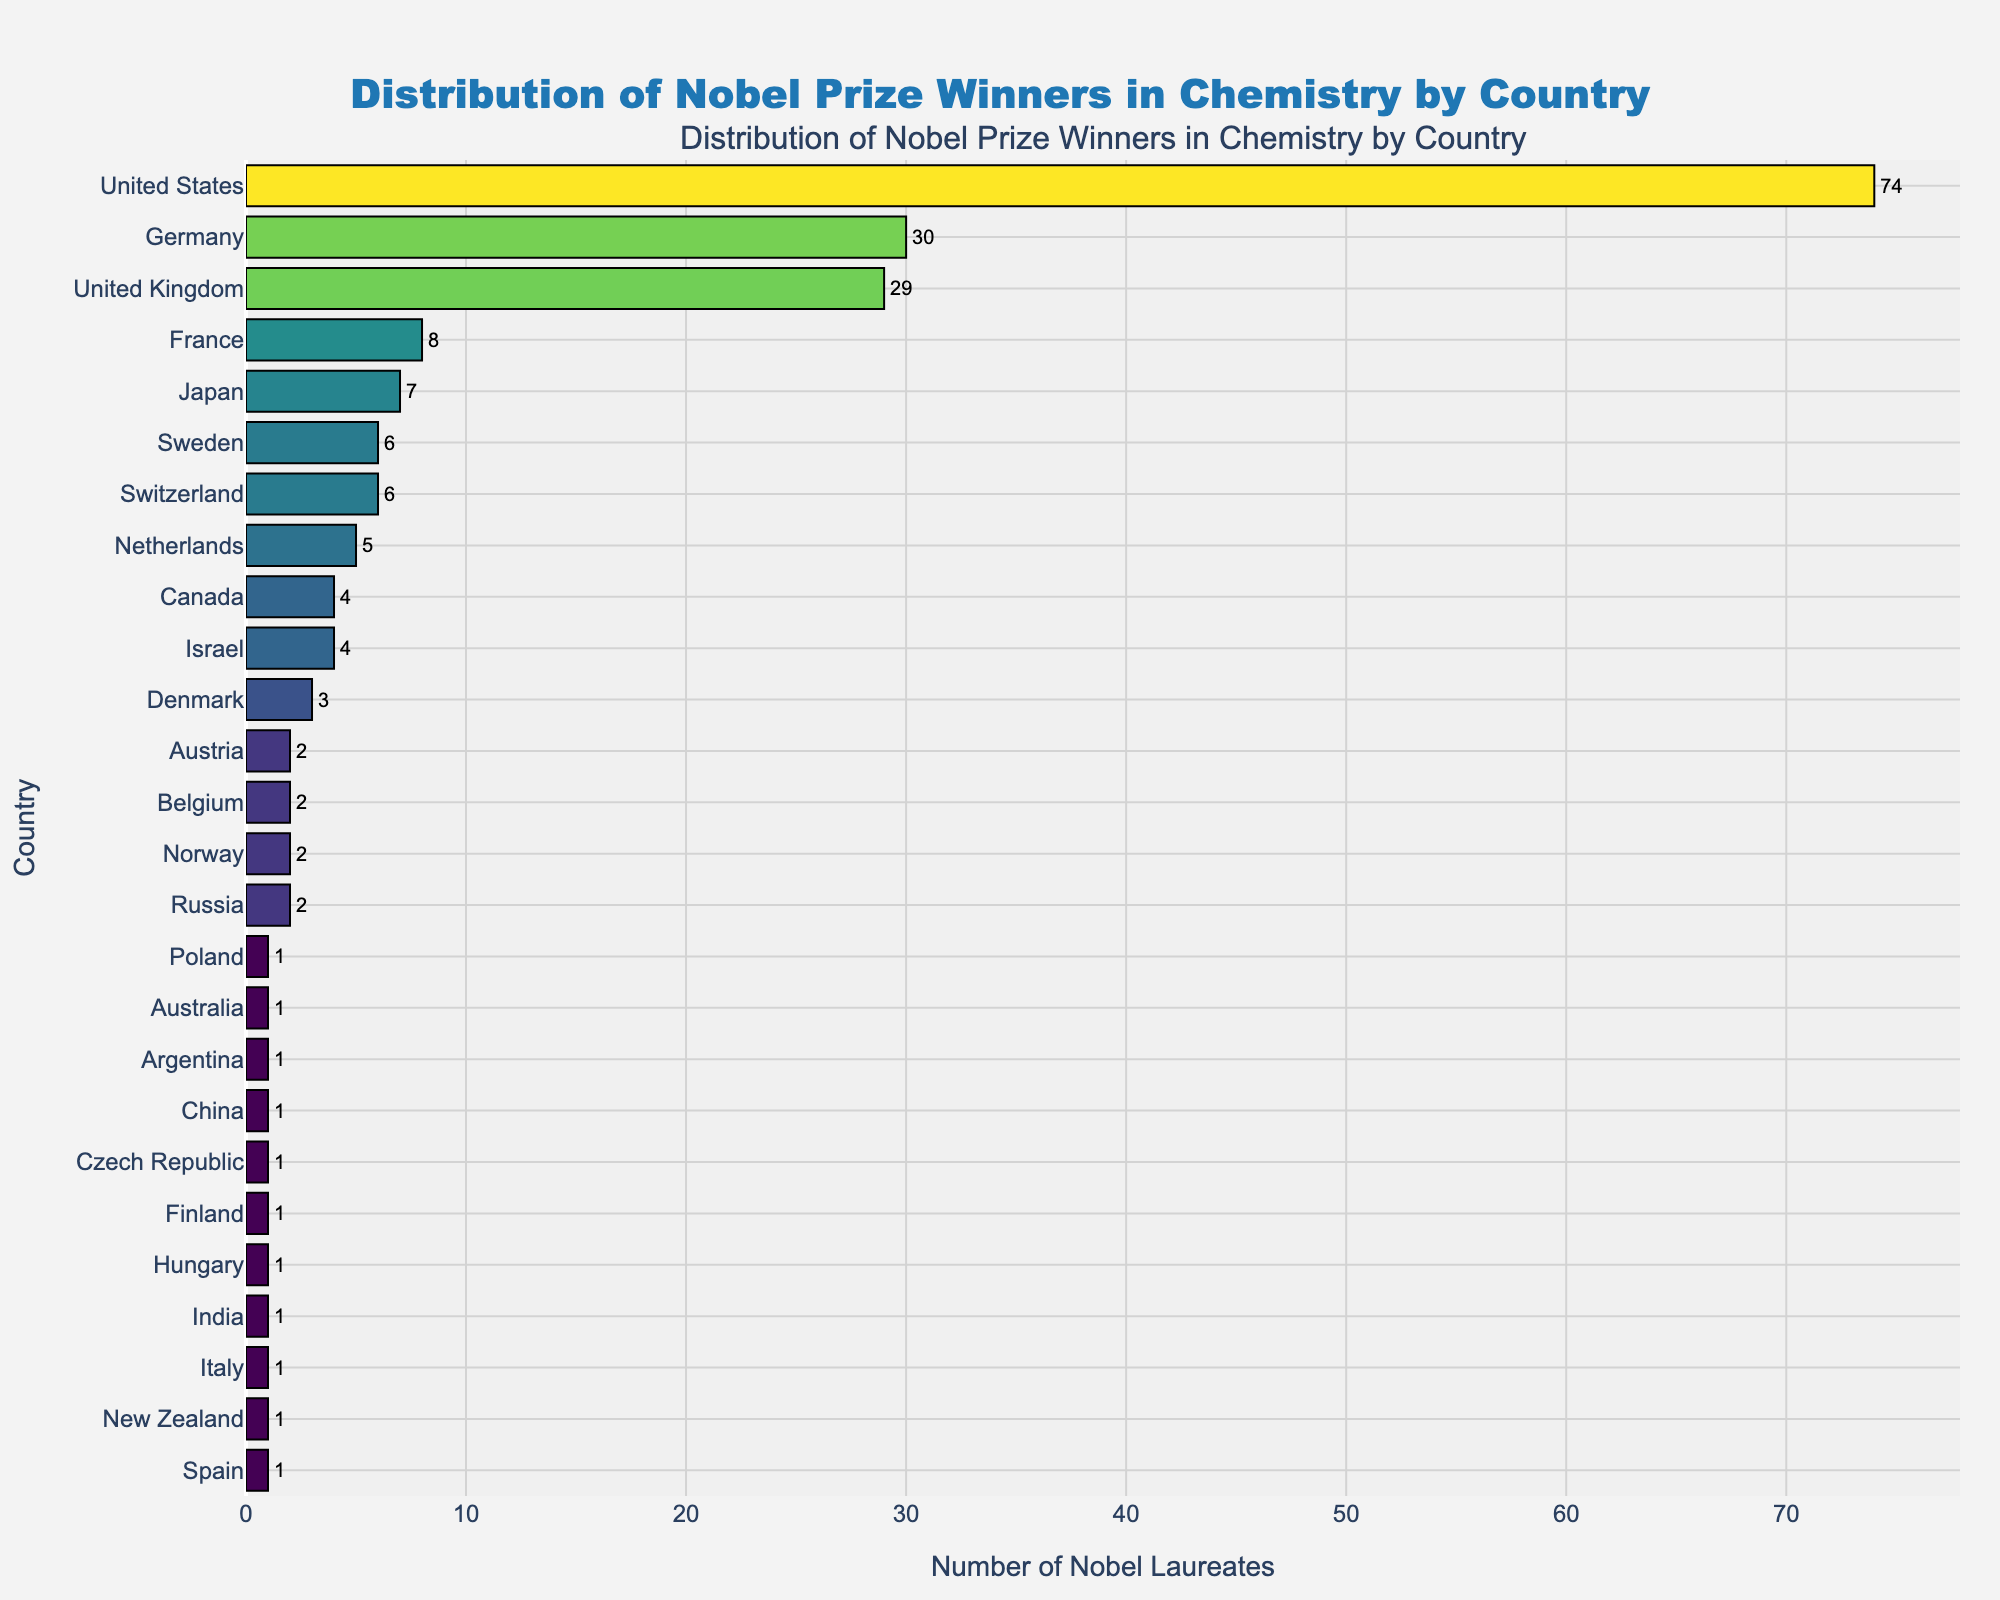Which country has the most Nobel Laureates in Chemistry? The bar corresponding to the United States is the longest and reaches the highest count on the x-axis.
Answer: United States What is the difference in the number of Nobel Laureates between Germany and the United Kingdom? Germany has 30 Nobel Laureates while the United Kingdom has 29, so the difference is 30 - 29.
Answer: 1 How many Nobel Laureates in total do the top three countries (United States, Germany, and United Kingdom) have? Adding the counts of the United States (74), Germany (30), and United Kingdom (29) gives the total: 74 + 30 + 29.
Answer: 133 Which countries have exactly two Nobel Laureates in Chemistry? The bars corresponding to Austria, Belgium, Norway, and Russia have labels showing a count of 2.
Answer: Austria, Belgium, Norway, Russia How many countries have only 1 Nobel Laureate in Chemistry? Count the bars with the value 1, which are: Australia, Argentina, China, Czech Republic, Finland, Hungary, India, Italy, New Zealand, Poland, and Spain.
Answer: 11 What is the total number of Nobel Laureates in Chemistry represented in this chart? Sum of all the values (74 + 30 + 29 + 8 + 7 + 6 + 6 + 5 + 4 + 4 + 3 + 2 + 2 + 2 + 2 + 1 + 1 + 1 + 1 + 1 + 1 + 1 + 1 + 1) gives the total number.
Answer: 193 Compare the number of Nobel Laureates in Chemistry between Japan and France. Which country has more? The bar for France shows 8 laureates while the bar for Japan shows 7.
Answer: France What is the median number of Nobel Laureates in Chemistry per country? Arrange the counts in ascending order and find the middle value, or average the two middle values if the number of values is even. The sorted counts are: 1, 1, 1, 1, 1, 1, 1, 1, 2, 2, 2, 2, 3, 4, 4, 5, 6, 6, 7, 8, 29, 30, 74. The middle value (13th) is 2.
Answer: 2 Among the countries with more than three Nobel Laureates in Chemistry, which one has the fewest? Out of the countries with more than three laureates (United States, Germany, United Kingdom, France, Japan, Sweden, Switzerland, Netherlands, Canada, Israel), Canada and Israel both have the fewest with 4 each.
Answer: Canada, Israel 